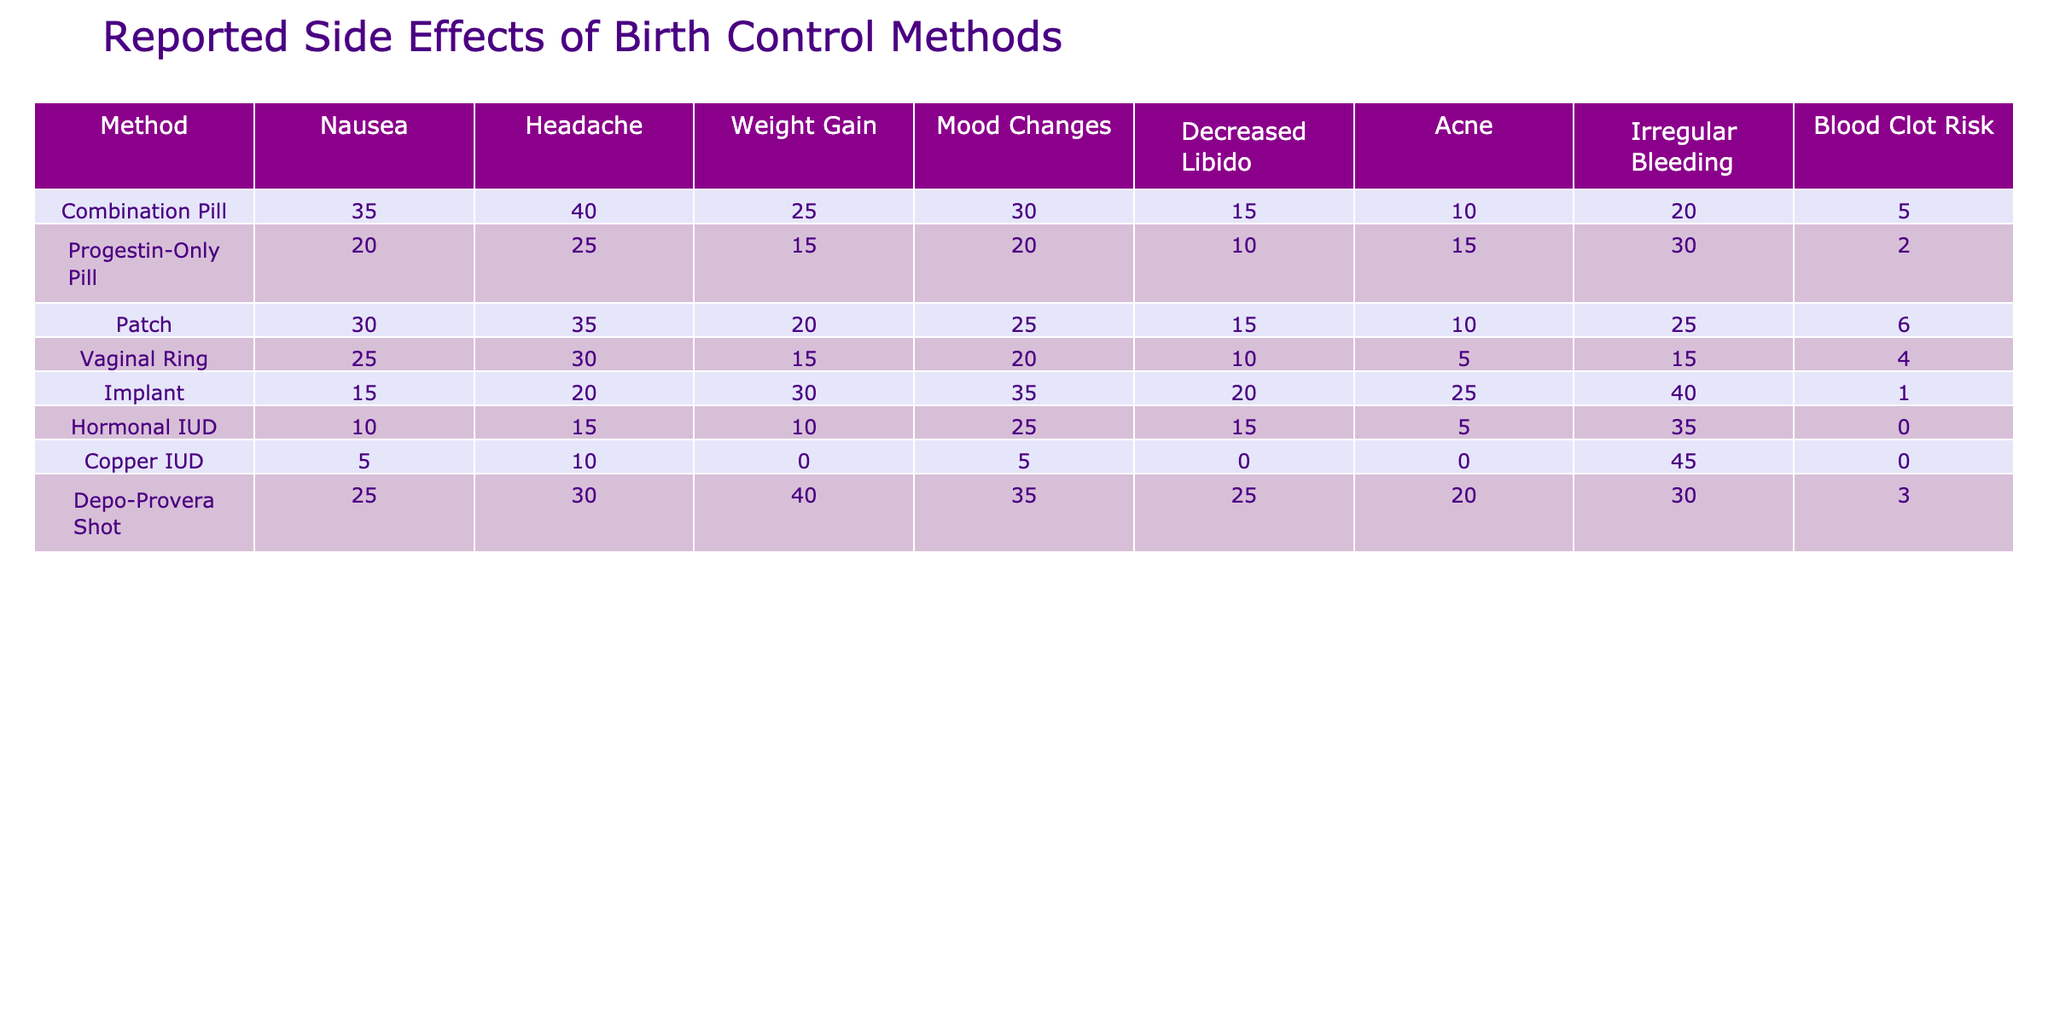What is the reported nausea percentage for the Progestin-Only Pill? The table shows that the reported nausea percentage for the Progestin-Only Pill is 20%.
Answer: 20% Which birth control method has the highest reported weight gain side effects? The Implant has the highest reported weight gain side effects at 30%.
Answer: 30% What is the average reported blood clot risk among all methods? To calculate the average blood clot risk, sum the values (5 + 2 + 6 + 4 + 1 + 0 + 0 + 3 = 21) and divide by the number of methods (8). The average is 21 / 8 = 2.625.
Answer: 2.625 Is it true that the Combination Pill has a higher percentage of reported headaches than the Copper IUD? The table shows the Combination Pill has 40% reported headaches, while the Copper IUD has 10%. Therefore, it is true.
Answer: Yes Which method shows the least risk for blood clots? The Hormonal IUD and the Copper IUD both have a reported blood clot risk of 0%, which is the least among all methods.
Answer: 0% How does the mood changes side effect for the Implant compare to the Patch? The Implant reports 35% for mood changes, while the Patch reports 25%. The Implant has a higher percentage of mood changes side effects than the Patch.
Answer: Higher If you sum up the reported irregular bleeding percentages of the Depo-Provera Shot and the Copper IUD, what do you get? The Depo-Provera Shot reports 30% and the Copper IUD reports 45%. Summing these gives 30 + 45 = 75%.
Answer: 75% Which birth control method has the lowest overall percentage of side effects reported? To determine this, compare the sum of reported side effects for each method. The Copper IUD has the lowest overall percentage of side effects summed at 55% (the least of all methods).
Answer: Copper IUD How much higher is the reported Nausea for the Combination Pill compared to the Hormonal IUD? The Combination Pill has 35% nausea and the Hormonal IUD has 10%, hence the difference is 35 - 10 = 25%.
Answer: 25% Are side effects generally reported more for hormonal methods compared to non-hormonal methods like the Copper IUD? Most hormonal methods listed (Combination Pill, Progestin-Only Pill, Patch, Implant, Hormonal IUD, and Depo-Provera Shot) show higher percentages for various side effects compared to the Copper IUD, which has notably lower reported side effects in comparison.
Answer: Yes 